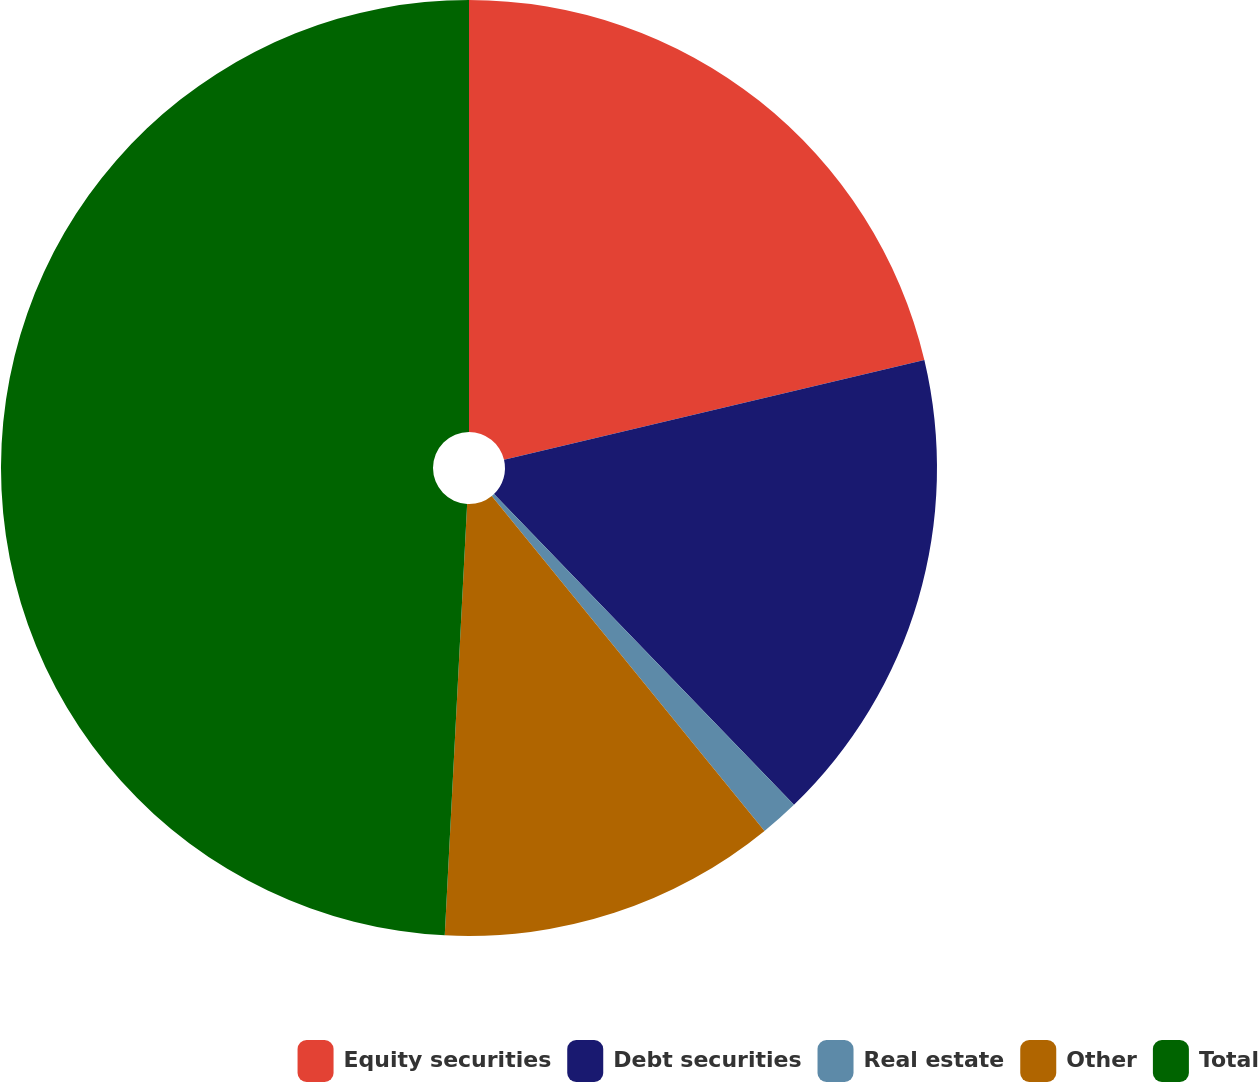Convert chart to OTSL. <chart><loc_0><loc_0><loc_500><loc_500><pie_chart><fcel>Equity securities<fcel>Debt securities<fcel>Real estate<fcel>Other<fcel>Total<nl><fcel>21.29%<fcel>16.49%<fcel>1.34%<fcel>11.7%<fcel>49.17%<nl></chart> 